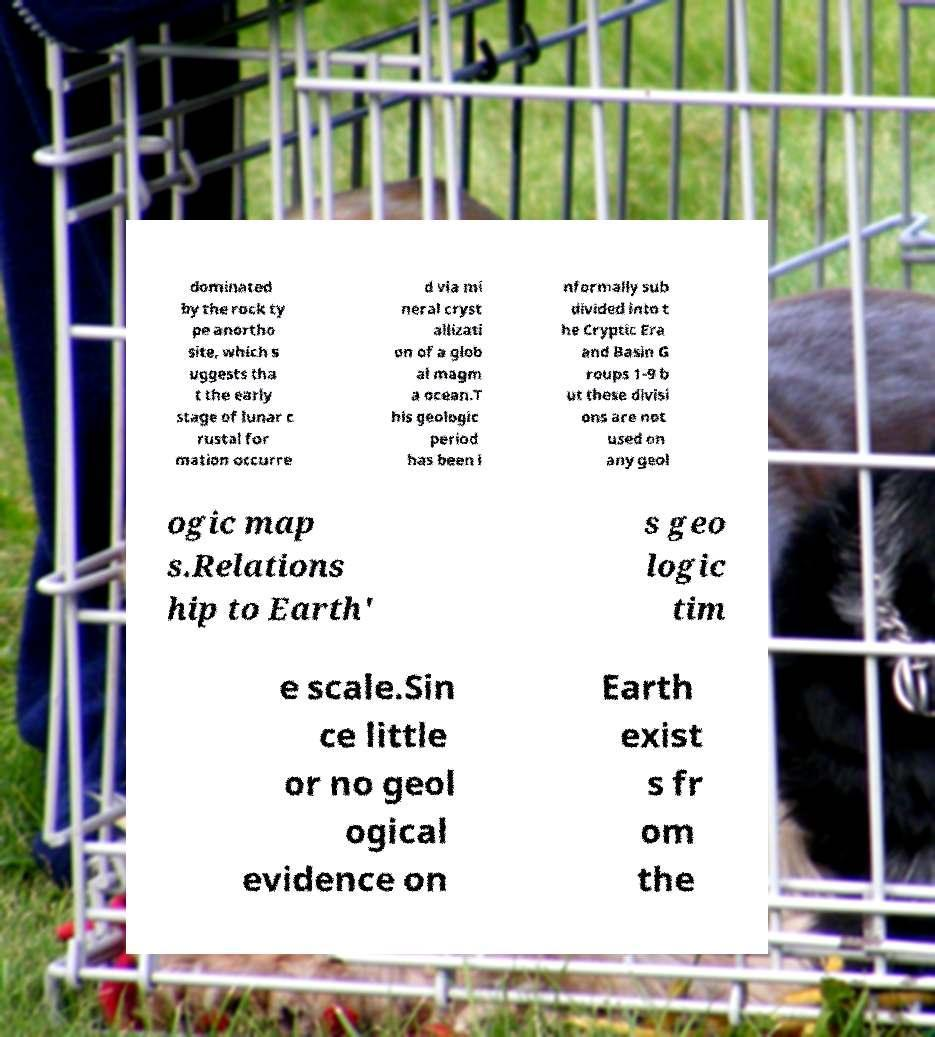Please identify and transcribe the text found in this image. dominated by the rock ty pe anortho site, which s uggests tha t the early stage of lunar c rustal for mation occurre d via mi neral cryst allizati on of a glob al magm a ocean.T his geologic period has been i nformally sub divided into t he Cryptic Era and Basin G roups 1-9 b ut these divisi ons are not used on any geol ogic map s.Relations hip to Earth' s geo logic tim e scale.Sin ce little or no geol ogical evidence on Earth exist s fr om the 